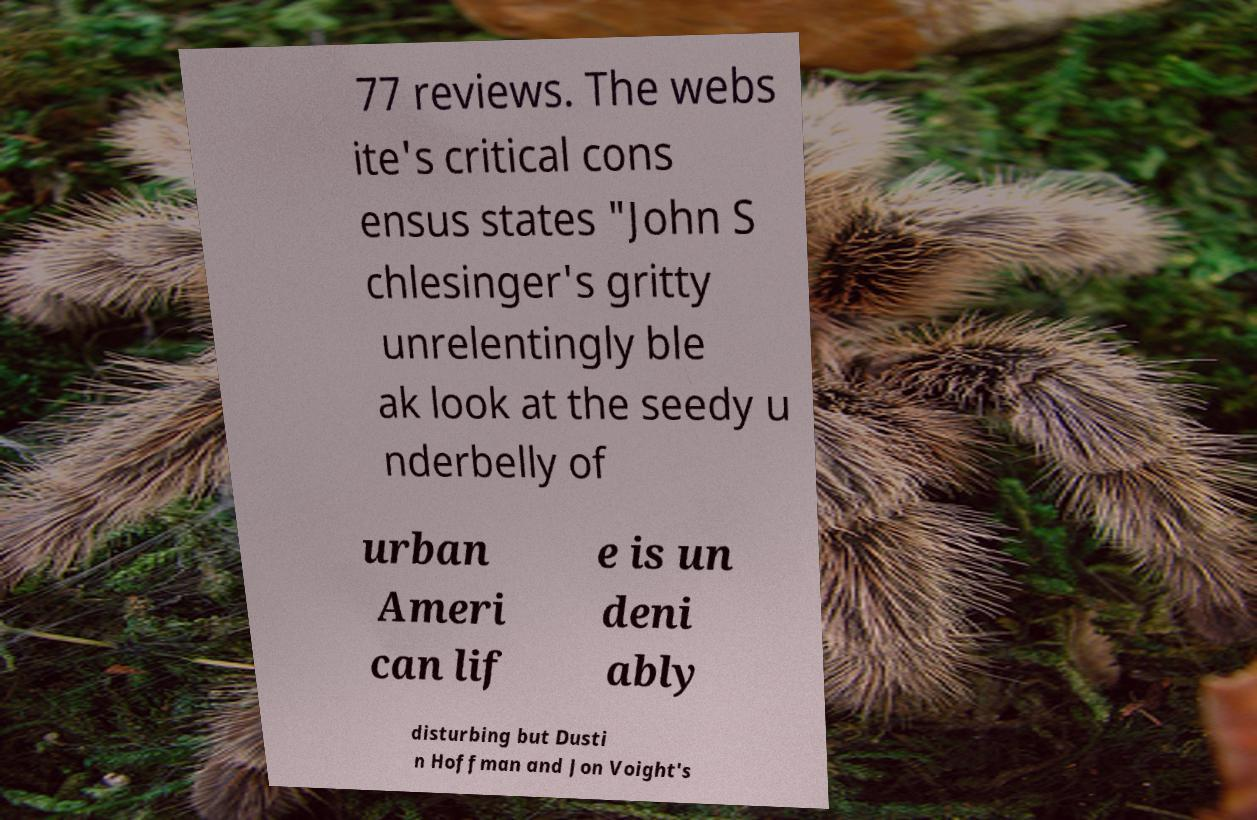Could you extract and type out the text from this image? 77 reviews. The webs ite's critical cons ensus states "John S chlesinger's gritty unrelentingly ble ak look at the seedy u nderbelly of urban Ameri can lif e is un deni ably disturbing but Dusti n Hoffman and Jon Voight's 